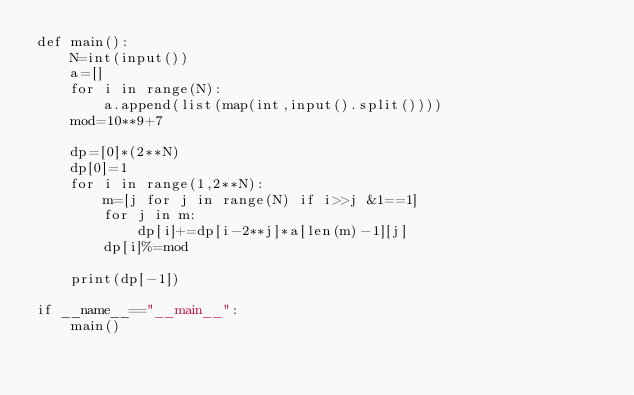Convert code to text. <code><loc_0><loc_0><loc_500><loc_500><_Python_>def main():
    N=int(input())
    a=[]
    for i in range(N):
        a.append(list(map(int,input().split())))
    mod=10**9+7

    dp=[0]*(2**N)
    dp[0]=1
    for i in range(1,2**N):
        m=[j for j in range(N) if i>>j &1==1]
        for j in m:
            dp[i]+=dp[i-2**j]*a[len(m)-1][j]
        dp[i]%=mod
    
    print(dp[-1])

if __name__=="__main__":
    main()</code> 